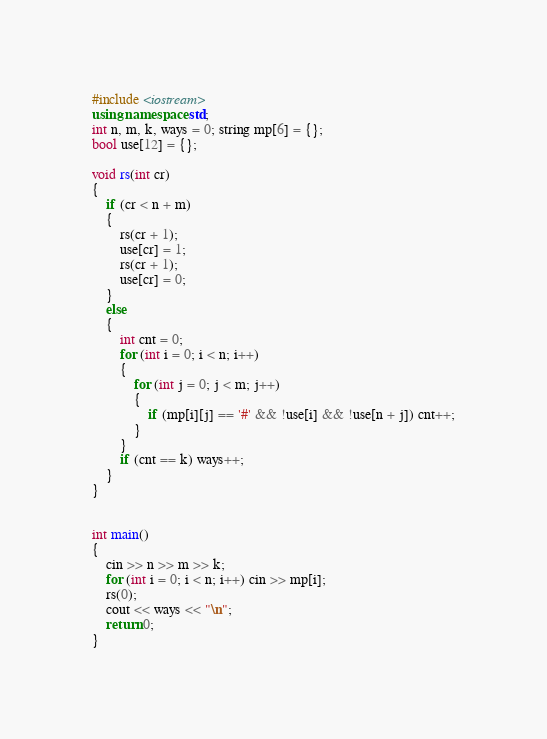Convert code to text. <code><loc_0><loc_0><loc_500><loc_500><_C++_>#include <iostream>
using namespace std;
int n, m, k, ways = 0; string mp[6] = {};
bool use[12] = {};

void rs(int cr)
{
	if (cr < n + m)
	{
		rs(cr + 1);
		use[cr] = 1;
		rs(cr + 1);
		use[cr] = 0;
	}
	else
	{
		int cnt = 0;
		for (int i = 0; i < n; i++)
		{
			for (int j = 0; j < m; j++)
			{
				if (mp[i][j] == '#' && !use[i] && !use[n + j]) cnt++;
			}
		}
		if (cnt == k) ways++;
	}
}


int main()
{
	cin >> n >> m >> k;
	for (int i = 0; i < n; i++) cin >> mp[i];
	rs(0);
	cout << ways << "\n";
	return 0;
}</code> 